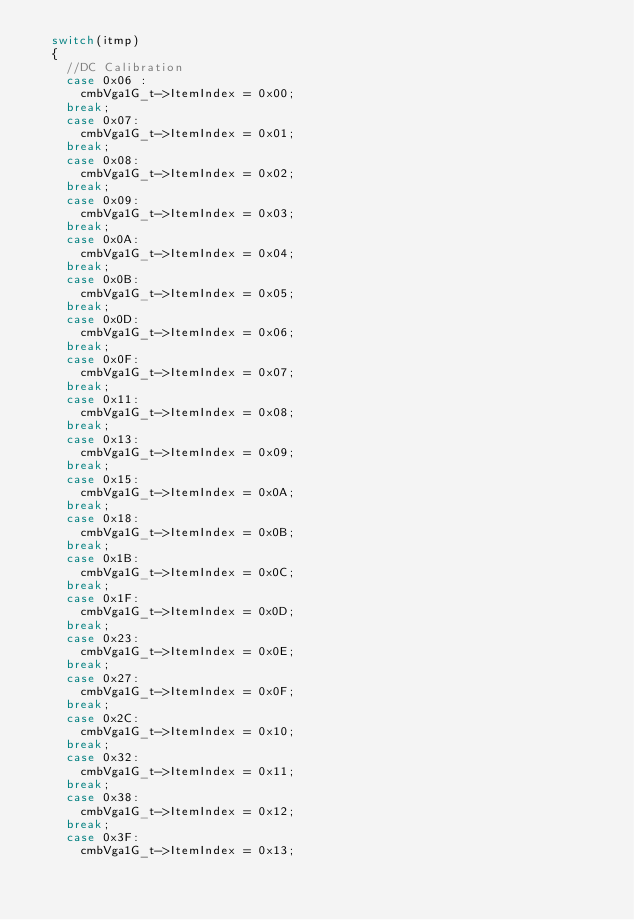Convert code to text. <code><loc_0><loc_0><loc_500><loc_500><_C++_>	switch(itmp)
	{
  	//DC Calibration
    case 0x06 :
    	cmbVga1G_t->ItemIndex = 0x00;
		break;
    case 0x07:
      cmbVga1G_t->ItemIndex = 0x01;
		break;
    case 0x08:
      cmbVga1G_t->ItemIndex = 0x02;
		break;
    case 0x09:
      cmbVga1G_t->ItemIndex = 0x03;
		break;
    case 0x0A:
      cmbVga1G_t->ItemIndex = 0x04;
		break;
    case 0x0B:
      cmbVga1G_t->ItemIndex = 0x05;
		break;
    case 0x0D:
      cmbVga1G_t->ItemIndex = 0x06;
		break;
    case 0x0F:
      cmbVga1G_t->ItemIndex = 0x07;
		break;
    case 0x11:
      cmbVga1G_t->ItemIndex = 0x08;
		break;
    case 0x13:
      cmbVga1G_t->ItemIndex = 0x09;
		break;
    case 0x15:
      cmbVga1G_t->ItemIndex = 0x0A;
		break;
    case 0x18:
      cmbVga1G_t->ItemIndex = 0x0B;
		break;
    case 0x1B:
      cmbVga1G_t->ItemIndex = 0x0C;
		break;
    case 0x1F:
      cmbVga1G_t->ItemIndex = 0x0D;
		break;
    case 0x23:
      cmbVga1G_t->ItemIndex = 0x0E;
		break;
    case 0x27:
      cmbVga1G_t->ItemIndex = 0x0F;
		break;
    case 0x2C:
      cmbVga1G_t->ItemIndex = 0x10;
		break;
    case 0x32:
      cmbVga1G_t->ItemIndex = 0x11;
		break;
    case 0x38:
      cmbVga1G_t->ItemIndex = 0x12;
		break;
    case 0x3F:
      cmbVga1G_t->ItemIndex = 0x13;</code> 